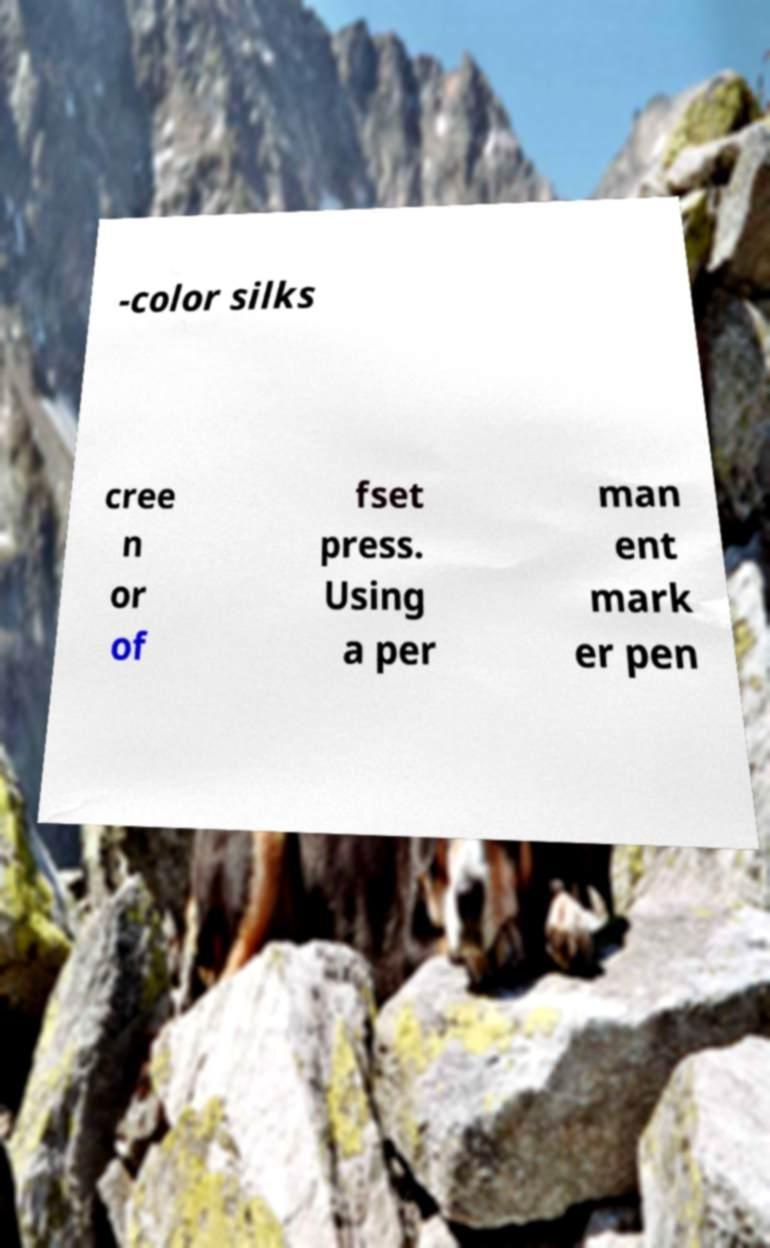Please read and relay the text visible in this image. What does it say? -color silks cree n or of fset press. Using a per man ent mark er pen 